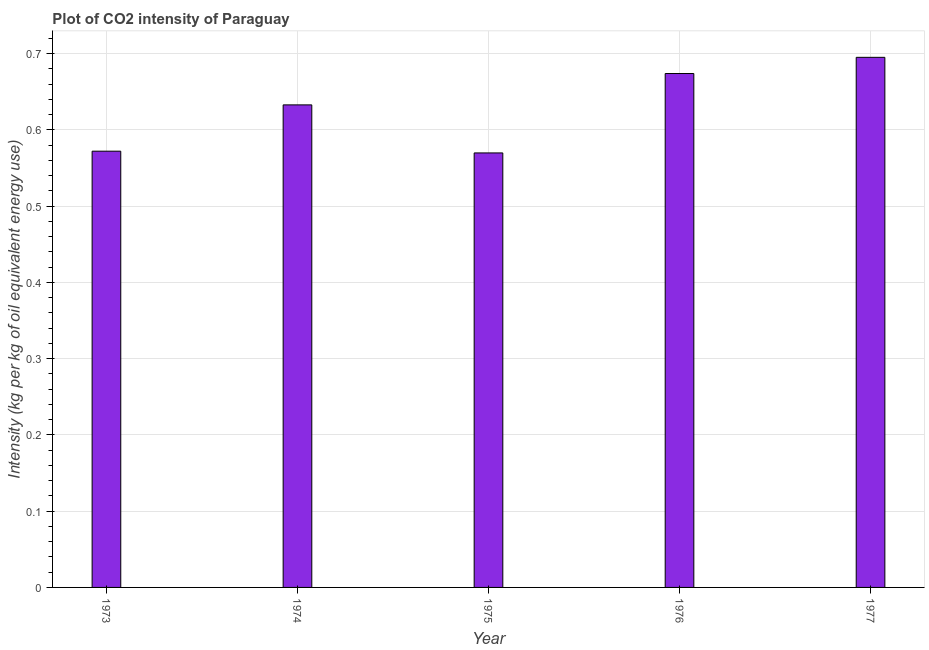What is the title of the graph?
Offer a very short reply. Plot of CO2 intensity of Paraguay. What is the label or title of the X-axis?
Your answer should be compact. Year. What is the label or title of the Y-axis?
Your answer should be very brief. Intensity (kg per kg of oil equivalent energy use). What is the co2 intensity in 1975?
Your answer should be very brief. 0.57. Across all years, what is the maximum co2 intensity?
Offer a terse response. 0.7. Across all years, what is the minimum co2 intensity?
Offer a terse response. 0.57. In which year was the co2 intensity maximum?
Your answer should be very brief. 1977. In which year was the co2 intensity minimum?
Your answer should be compact. 1975. What is the sum of the co2 intensity?
Offer a terse response. 3.14. What is the difference between the co2 intensity in 1973 and 1976?
Ensure brevity in your answer.  -0.1. What is the average co2 intensity per year?
Provide a succinct answer. 0.63. What is the median co2 intensity?
Give a very brief answer. 0.63. In how many years, is the co2 intensity greater than 0.4 kg?
Make the answer very short. 5. Do a majority of the years between 1975 and 1974 (inclusive) have co2 intensity greater than 0.04 kg?
Your answer should be compact. No. What is the ratio of the co2 intensity in 1975 to that in 1976?
Your response must be concise. 0.84. What is the difference between the highest and the second highest co2 intensity?
Your answer should be very brief. 0.02. Is the sum of the co2 intensity in 1973 and 1976 greater than the maximum co2 intensity across all years?
Your answer should be compact. Yes. What is the difference between the highest and the lowest co2 intensity?
Provide a succinct answer. 0.13. In how many years, is the co2 intensity greater than the average co2 intensity taken over all years?
Provide a succinct answer. 3. What is the difference between two consecutive major ticks on the Y-axis?
Offer a terse response. 0.1. What is the Intensity (kg per kg of oil equivalent energy use) in 1973?
Provide a short and direct response. 0.57. What is the Intensity (kg per kg of oil equivalent energy use) in 1974?
Make the answer very short. 0.63. What is the Intensity (kg per kg of oil equivalent energy use) in 1975?
Provide a short and direct response. 0.57. What is the Intensity (kg per kg of oil equivalent energy use) of 1976?
Give a very brief answer. 0.67. What is the Intensity (kg per kg of oil equivalent energy use) of 1977?
Offer a very short reply. 0.7. What is the difference between the Intensity (kg per kg of oil equivalent energy use) in 1973 and 1974?
Give a very brief answer. -0.06. What is the difference between the Intensity (kg per kg of oil equivalent energy use) in 1973 and 1975?
Your answer should be compact. 0. What is the difference between the Intensity (kg per kg of oil equivalent energy use) in 1973 and 1976?
Your answer should be very brief. -0.1. What is the difference between the Intensity (kg per kg of oil equivalent energy use) in 1973 and 1977?
Give a very brief answer. -0.12. What is the difference between the Intensity (kg per kg of oil equivalent energy use) in 1974 and 1975?
Offer a terse response. 0.06. What is the difference between the Intensity (kg per kg of oil equivalent energy use) in 1974 and 1976?
Keep it short and to the point. -0.04. What is the difference between the Intensity (kg per kg of oil equivalent energy use) in 1974 and 1977?
Your response must be concise. -0.06. What is the difference between the Intensity (kg per kg of oil equivalent energy use) in 1975 and 1976?
Make the answer very short. -0.1. What is the difference between the Intensity (kg per kg of oil equivalent energy use) in 1975 and 1977?
Offer a very short reply. -0.13. What is the difference between the Intensity (kg per kg of oil equivalent energy use) in 1976 and 1977?
Your answer should be compact. -0.02. What is the ratio of the Intensity (kg per kg of oil equivalent energy use) in 1973 to that in 1974?
Your answer should be very brief. 0.9. What is the ratio of the Intensity (kg per kg of oil equivalent energy use) in 1973 to that in 1976?
Offer a very short reply. 0.85. What is the ratio of the Intensity (kg per kg of oil equivalent energy use) in 1973 to that in 1977?
Offer a very short reply. 0.82. What is the ratio of the Intensity (kg per kg of oil equivalent energy use) in 1974 to that in 1975?
Give a very brief answer. 1.11. What is the ratio of the Intensity (kg per kg of oil equivalent energy use) in 1974 to that in 1976?
Offer a terse response. 0.94. What is the ratio of the Intensity (kg per kg of oil equivalent energy use) in 1974 to that in 1977?
Make the answer very short. 0.91. What is the ratio of the Intensity (kg per kg of oil equivalent energy use) in 1975 to that in 1976?
Your answer should be very brief. 0.84. What is the ratio of the Intensity (kg per kg of oil equivalent energy use) in 1975 to that in 1977?
Ensure brevity in your answer.  0.82. What is the ratio of the Intensity (kg per kg of oil equivalent energy use) in 1976 to that in 1977?
Your response must be concise. 0.97. 